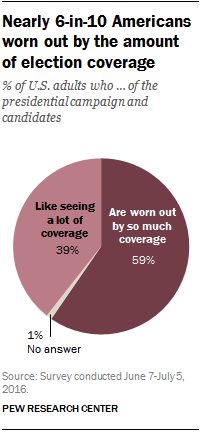Specify some key components in this picture. The result of taking the sum of the smallest and largest segments, dividing it by the second largest segment, and rounding it to one decimal place is 1.5. According to a recent survey, only 0.01% of U.S. adults were unable to provide a response when asked a question. 